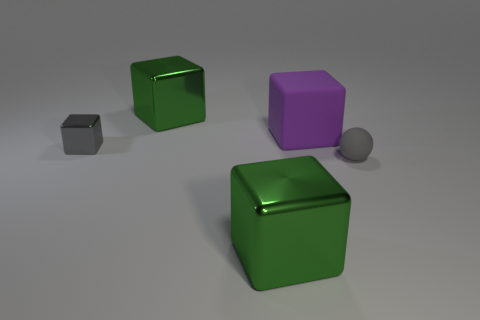Subtract all big blocks. How many blocks are left? 1 Subtract all brown cylinders. How many green blocks are left? 2 Subtract all gray blocks. How many blocks are left? 3 Add 2 tiny cubes. How many objects exist? 7 Subtract all cubes. How many objects are left? 1 Add 3 rubber balls. How many rubber balls are left? 4 Add 1 green metallic things. How many green metallic things exist? 3 Subtract 1 purple blocks. How many objects are left? 4 Subtract all red blocks. Subtract all yellow cylinders. How many blocks are left? 4 Subtract all gray rubber things. Subtract all gray blocks. How many objects are left? 3 